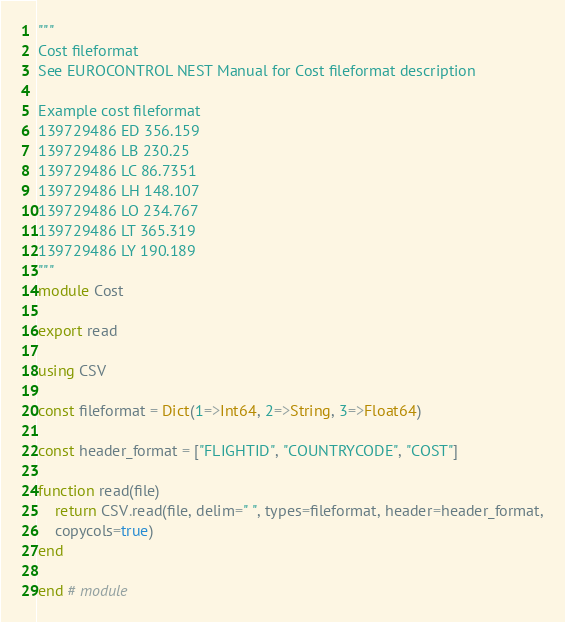Convert code to text. <code><loc_0><loc_0><loc_500><loc_500><_Julia_>"""
Cost fileformat
See EUROCONTROL NEST Manual for Cost fileformat description

Example cost fileformat
139729486 ED 356.159
139729486 LB 230.25
139729486 LC 86.7351
139729486 LH 148.107
139729486 LO 234.767
139729486 LT 365.319
139729486 LY 190.189
"""
module Cost

export read

using CSV

const fileformat = Dict(1=>Int64, 2=>String, 3=>Float64)

const header_format = ["FLIGHTID", "COUNTRYCODE", "COST"]

function read(file)
    return CSV.read(file, delim=" ", types=fileformat, header=header_format,
    copycols=true)
end

end # module
</code> 